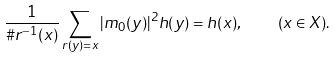<formula> <loc_0><loc_0><loc_500><loc_500>\frac { 1 } { \# r ^ { - 1 } ( x ) } \sum _ { r ( y ) = x } | m _ { 0 } ( y ) | ^ { 2 } h ( y ) = h ( x ) , \quad ( x \in X ) .</formula> 